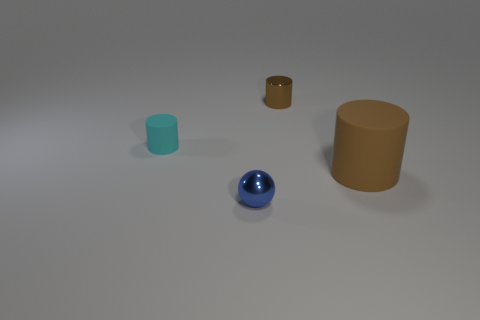Subtract all tiny cylinders. How many cylinders are left? 1 Add 2 brown rubber spheres. How many objects exist? 6 Subtract all brown cylinders. How many cylinders are left? 1 Subtract 3 cylinders. How many cylinders are left? 0 Subtract all yellow blocks. How many brown cylinders are left? 2 Subtract all cylinders. How many objects are left? 1 Add 3 large red spheres. How many large red spheres exist? 3 Subtract 0 blue cubes. How many objects are left? 4 Subtract all purple cylinders. Subtract all blue blocks. How many cylinders are left? 3 Subtract all cyan metal things. Subtract all small metal balls. How many objects are left? 3 